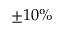<formula> <loc_0><loc_0><loc_500><loc_500>\pm 1 0 \%</formula> 